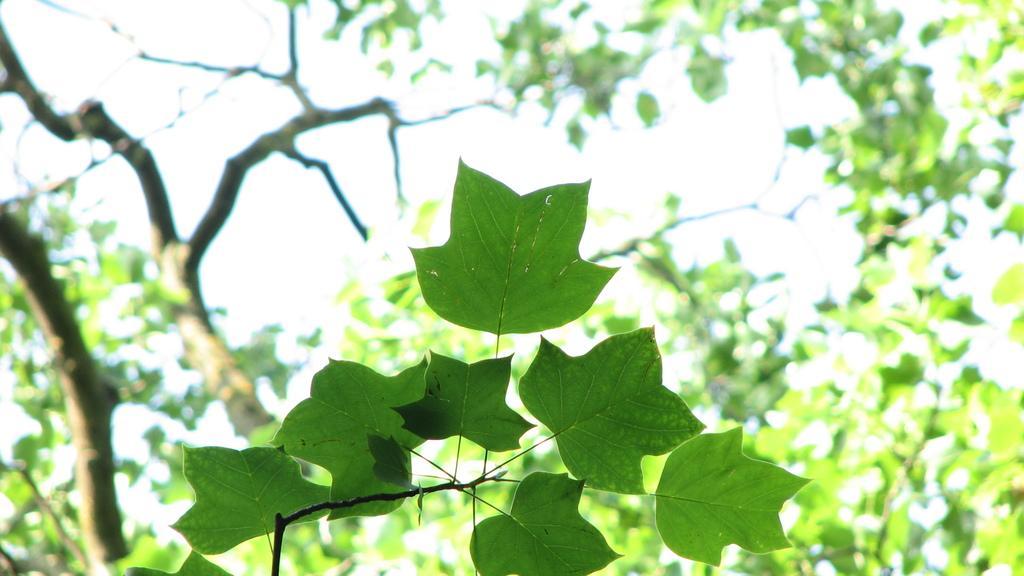In one or two sentences, can you explain what this image depicts? In the down side these are the leaves of a plant and here it is a tree in the back side of an image. 